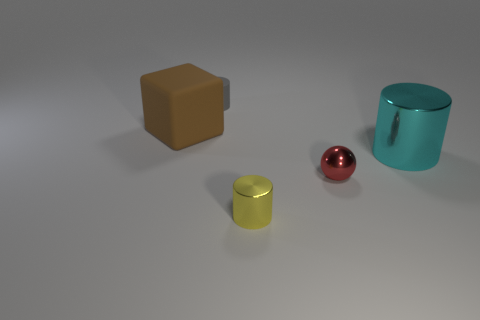Subtract all metal cylinders. How many cylinders are left? 1 Add 4 tiny yellow cylinders. How many objects exist? 9 Subtract all cubes. How many objects are left? 4 Add 2 gray cylinders. How many gray cylinders are left? 3 Add 4 big gray matte cubes. How many big gray matte cubes exist? 4 Subtract 0 brown spheres. How many objects are left? 5 Subtract all big blocks. Subtract all shiny objects. How many objects are left? 1 